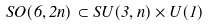Convert formula to latex. <formula><loc_0><loc_0><loc_500><loc_500>S O ( 6 , 2 n ) \subset S U ( 3 , n ) \times U ( 1 )</formula> 